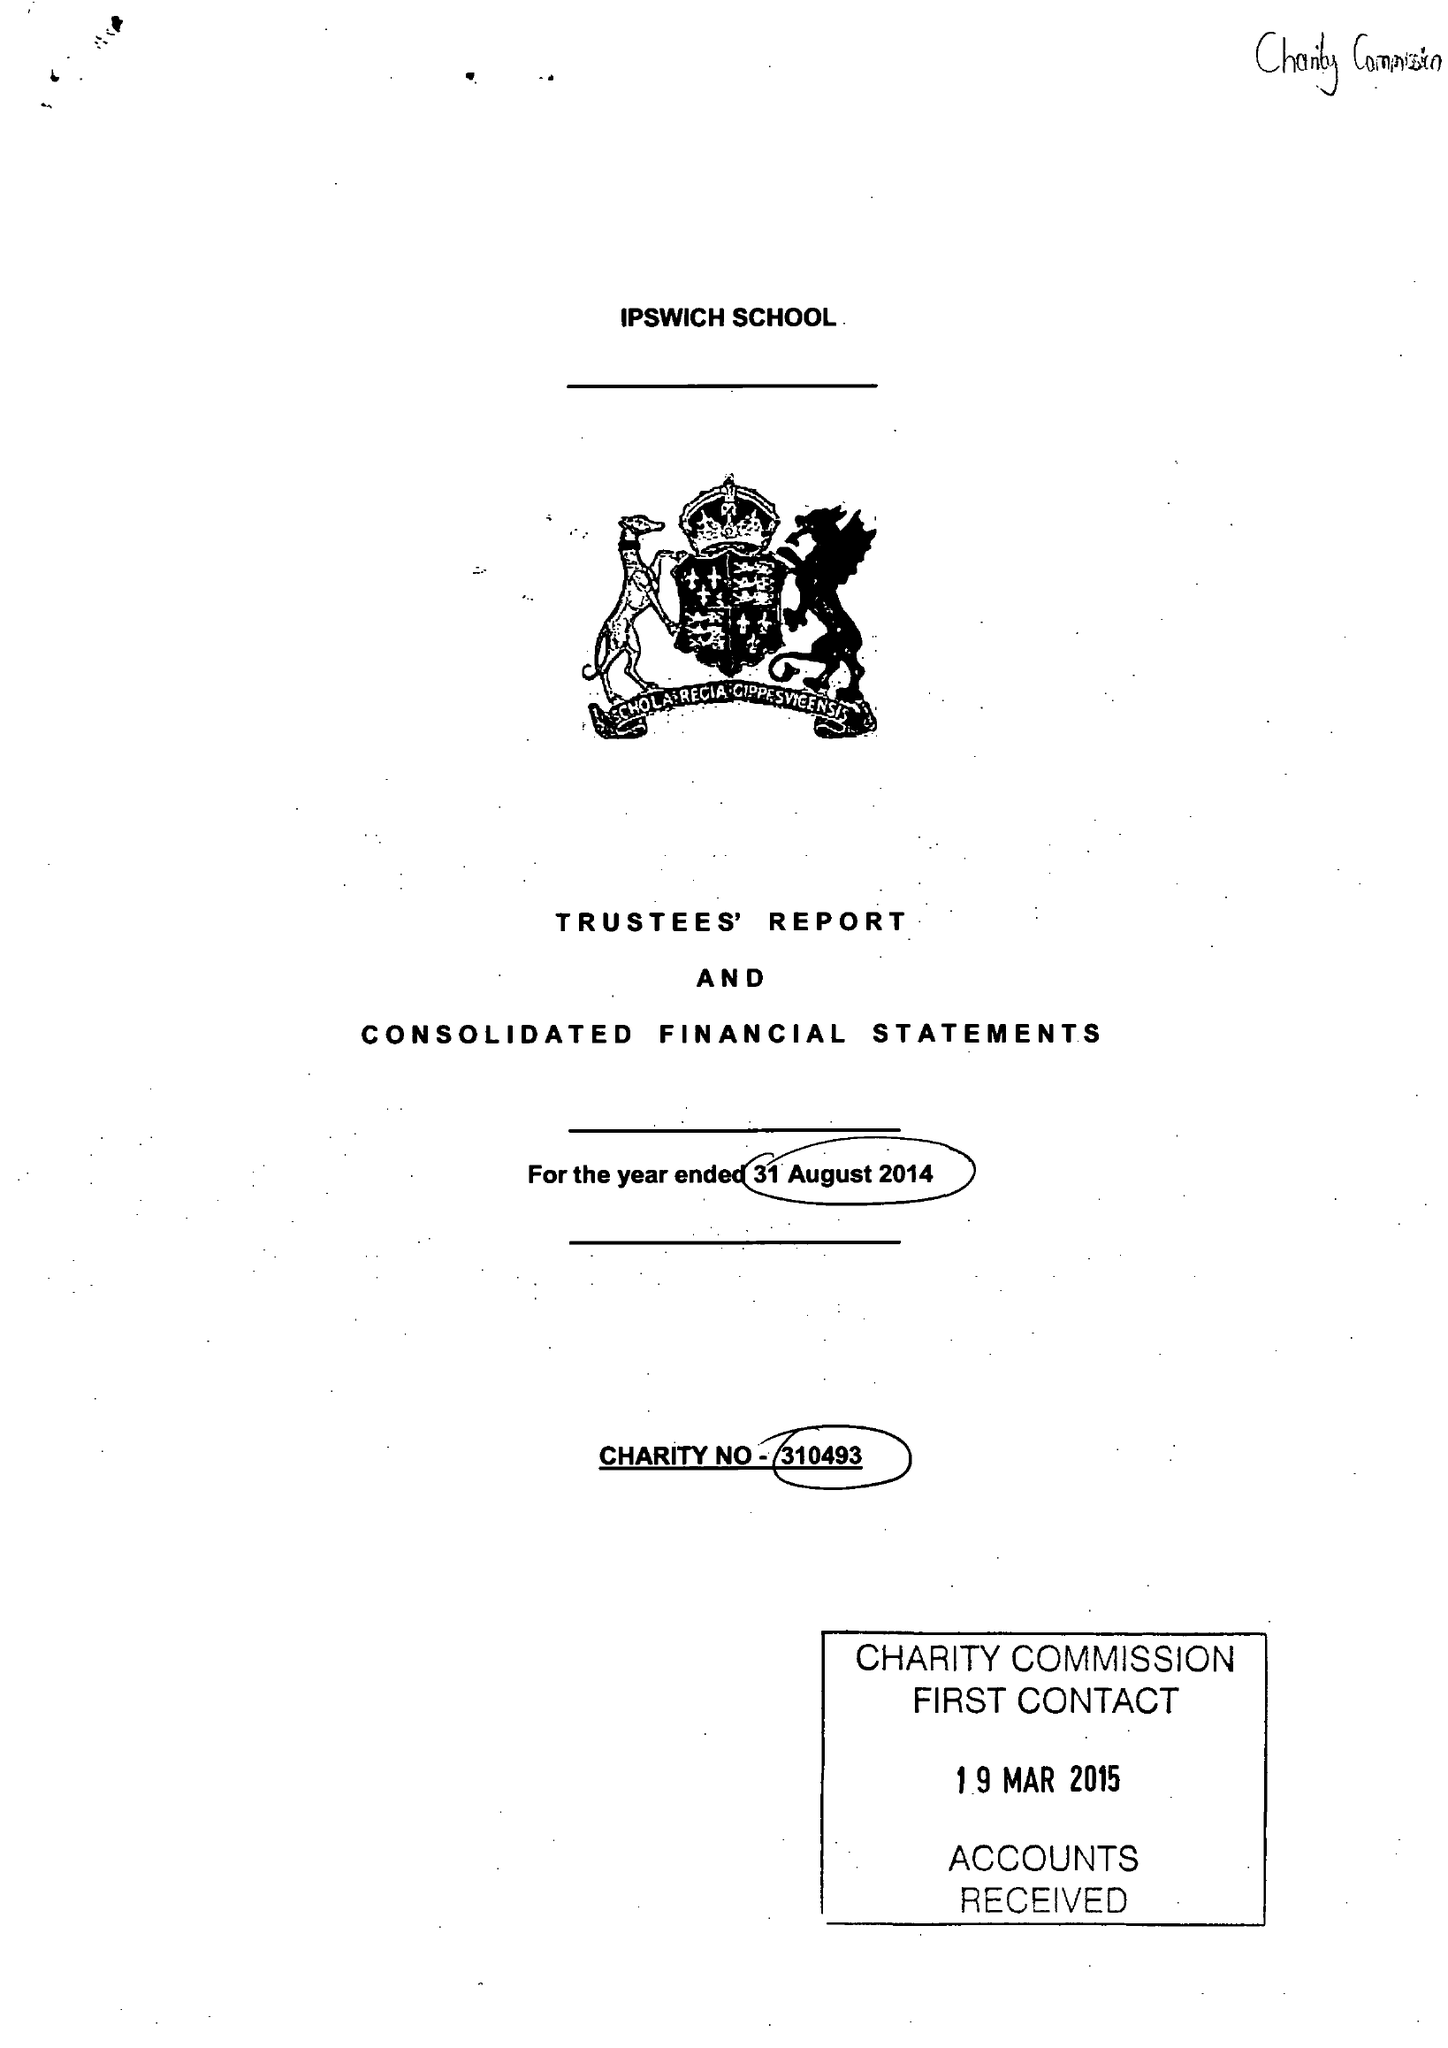What is the value for the income_annually_in_british_pounds?
Answer the question using a single word or phrase. 13099137.00 